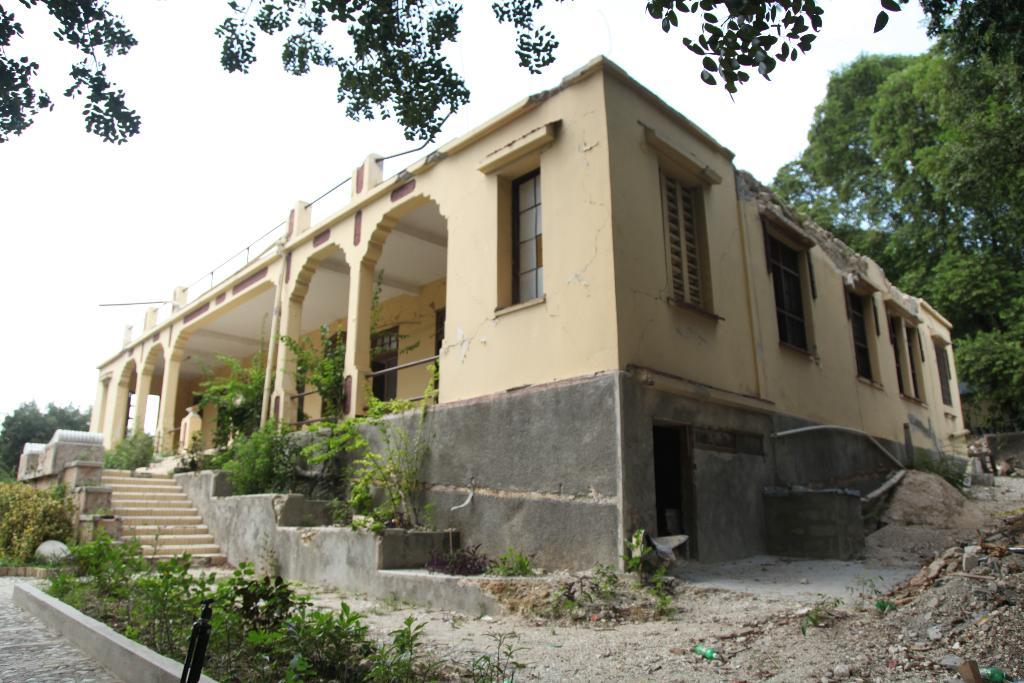What type of structure is present in the image? There is a building in the image. What feature of the building is mentioned in the facts? The building has windows. Are there any architectural elements visible in the image? Yes, there are stairs in the image. What type of natural elements can be seen in the image? There are trees and plants in the image. What is visible in the background of the image? The sky is visible in the image. How many bears can be seen climbing the trees in the image? There are no bears present in the image; it features a building, stairs, trees, plants, and the sky. What type of owl is perched on the roof of the building in the image? There is no owl present on the roof of the building in the image. 